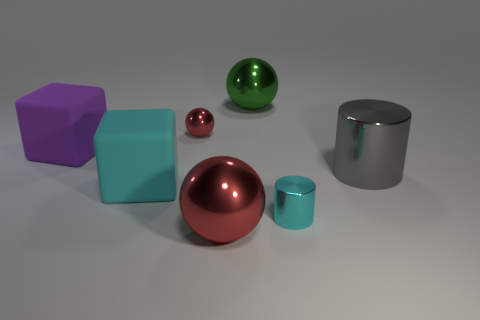Add 2 small yellow cubes. How many objects exist? 9 Subtract all cyan cubes. Subtract all green cylinders. How many cubes are left? 1 Subtract all blocks. How many objects are left? 5 Add 2 large cubes. How many large cubes are left? 4 Add 3 big green objects. How many big green objects exist? 4 Subtract 0 blue balls. How many objects are left? 7 Subtract all tiny shiny cylinders. Subtract all small red balls. How many objects are left? 5 